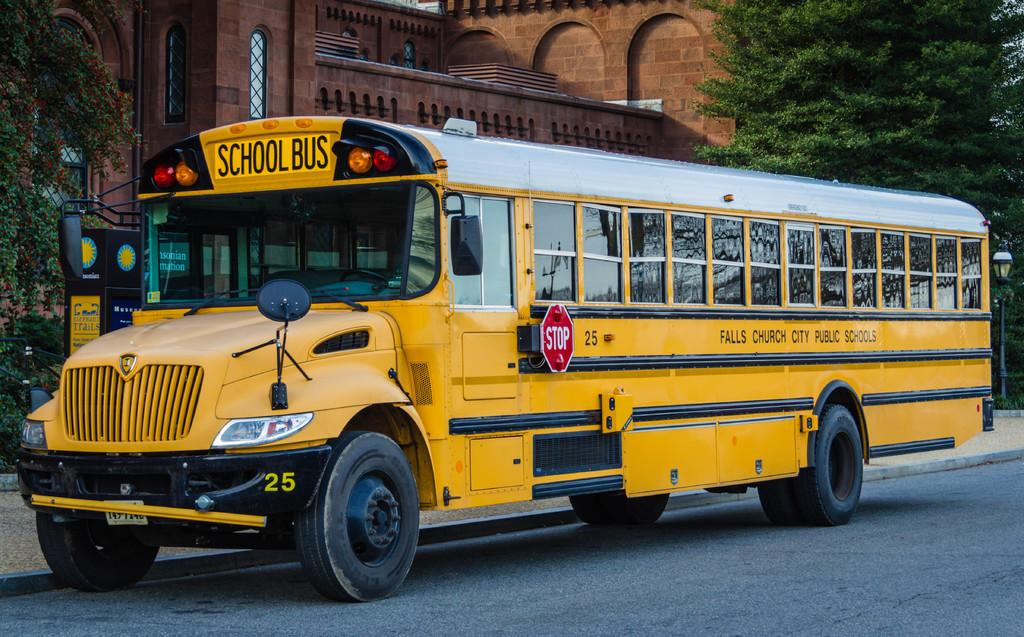What type of vehicle is on the road in the image? There is a school bus on the road in the image. What can be seen in the background of the image? There is a building in the background. What type of vegetation is present on either side of the bus? There are trees on either side of the bus. What news is being reported on the canvas in the image? There is no canvas or news report present in the image. 